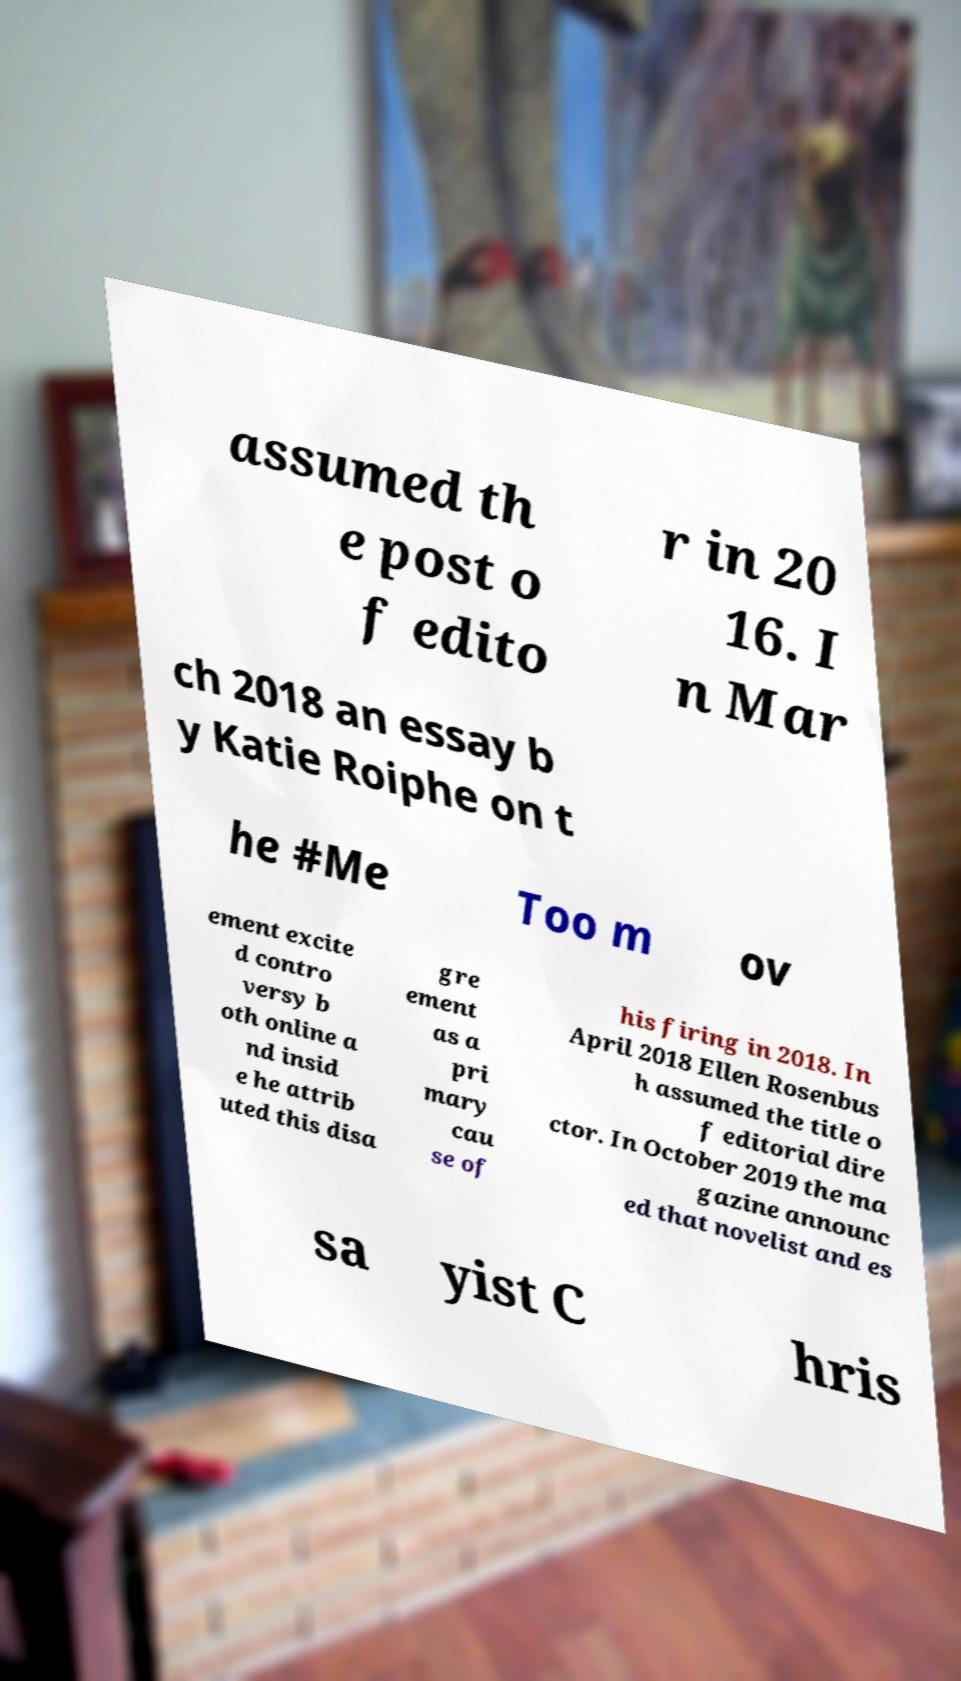Can you read and provide the text displayed in the image?This photo seems to have some interesting text. Can you extract and type it out for me? assumed th e post o f edito r in 20 16. I n Mar ch 2018 an essay b y Katie Roiphe on t he #Me Too m ov ement excite d contro versy b oth online a nd insid e he attrib uted this disa gre ement as a pri mary cau se of his firing in 2018. In April 2018 Ellen Rosenbus h assumed the title o f editorial dire ctor. In October 2019 the ma gazine announc ed that novelist and es sa yist C hris 